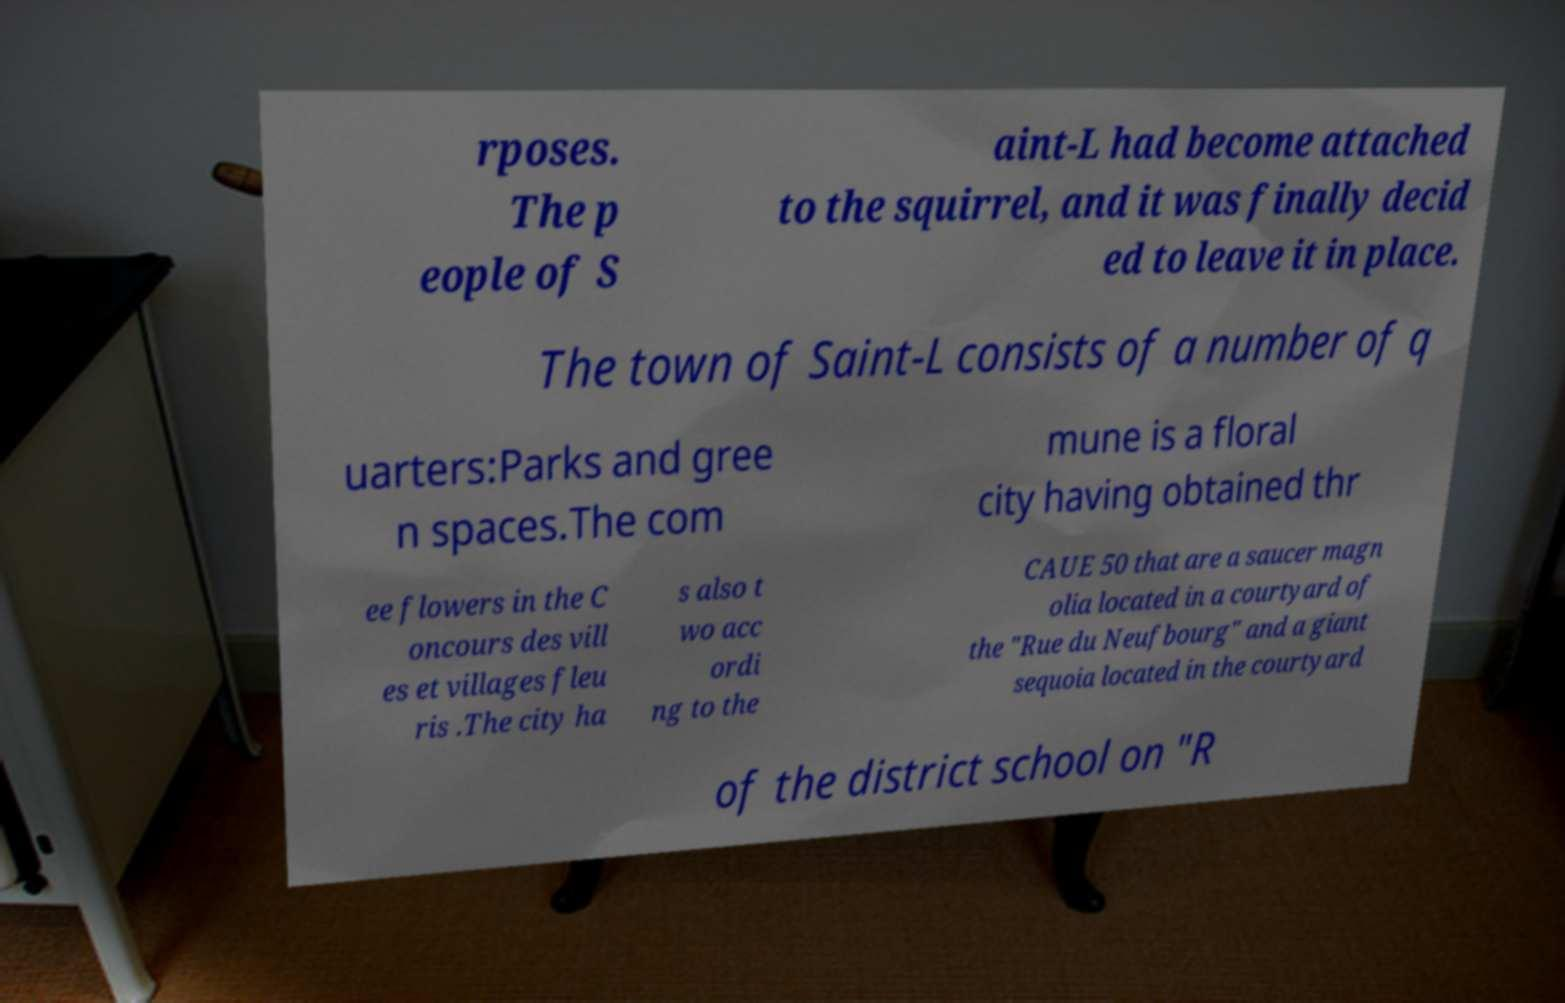There's text embedded in this image that I need extracted. Can you transcribe it verbatim? rposes. The p eople of S aint-L had become attached to the squirrel, and it was finally decid ed to leave it in place. The town of Saint-L consists of a number of q uarters:Parks and gree n spaces.The com mune is a floral city having obtained thr ee flowers in the C oncours des vill es et villages fleu ris .The city ha s also t wo acc ordi ng to the CAUE 50 that are a saucer magn olia located in a courtyard of the "Rue du Neufbourg" and a giant sequoia located in the courtyard of the district school on "R 